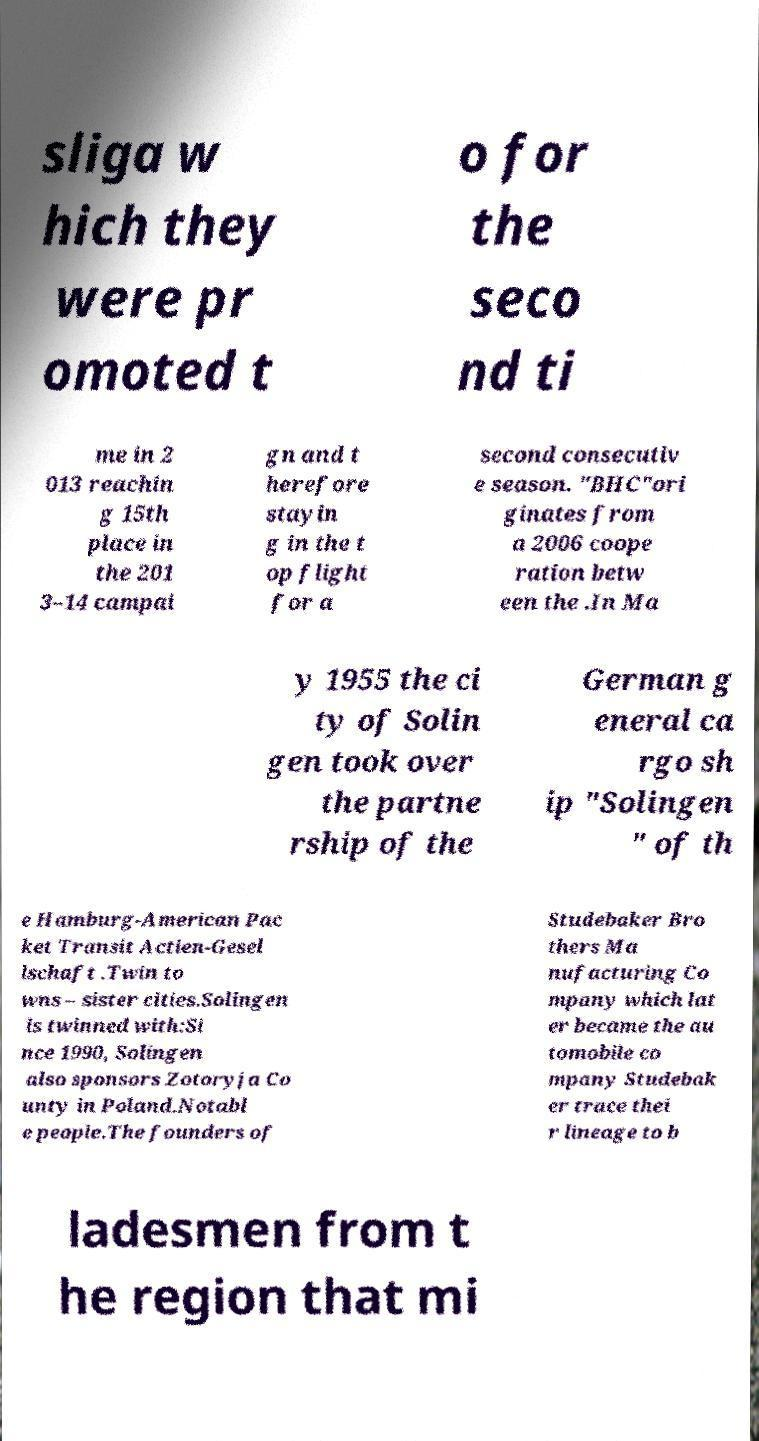What messages or text are displayed in this image? I need them in a readable, typed format. sliga w hich they were pr omoted t o for the seco nd ti me in 2 013 reachin g 15th place in the 201 3–14 campai gn and t herefore stayin g in the t op flight for a second consecutiv e season. "BHC"ori ginates from a 2006 coope ration betw een the .In Ma y 1955 the ci ty of Solin gen took over the partne rship of the German g eneral ca rgo sh ip "Solingen " of th e Hamburg-American Pac ket Transit Actien-Gesel lschaft .Twin to wns – sister cities.Solingen is twinned with:Si nce 1990, Solingen also sponsors Zotoryja Co unty in Poland.Notabl e people.The founders of Studebaker Bro thers Ma nufacturing Co mpany which lat er became the au tomobile co mpany Studebak er trace thei r lineage to b ladesmen from t he region that mi 